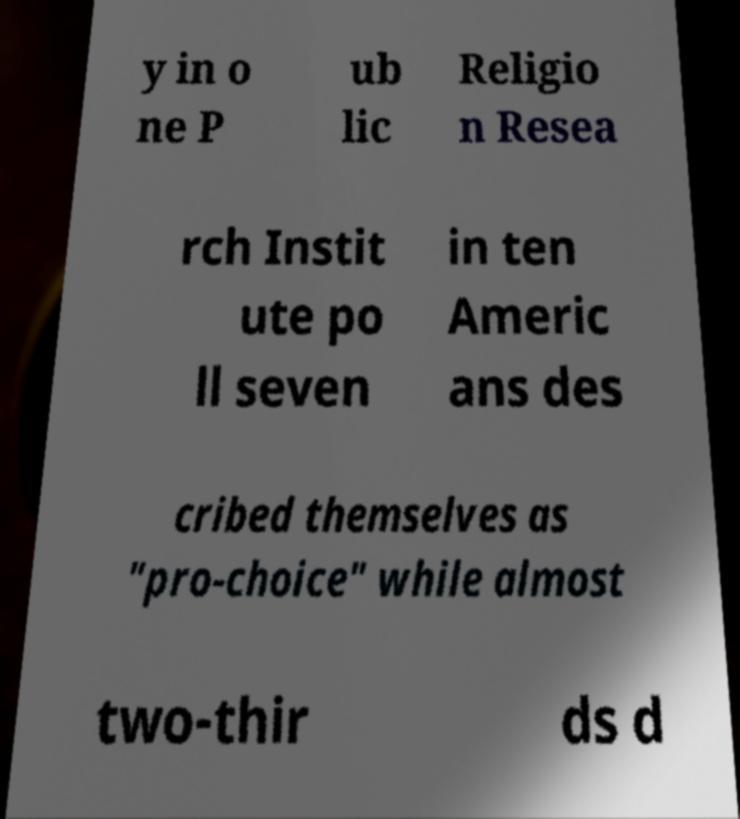Can you read and provide the text displayed in the image?This photo seems to have some interesting text. Can you extract and type it out for me? y in o ne P ub lic Religio n Resea rch Instit ute po ll seven in ten Americ ans des cribed themselves as "pro-choice" while almost two-thir ds d 